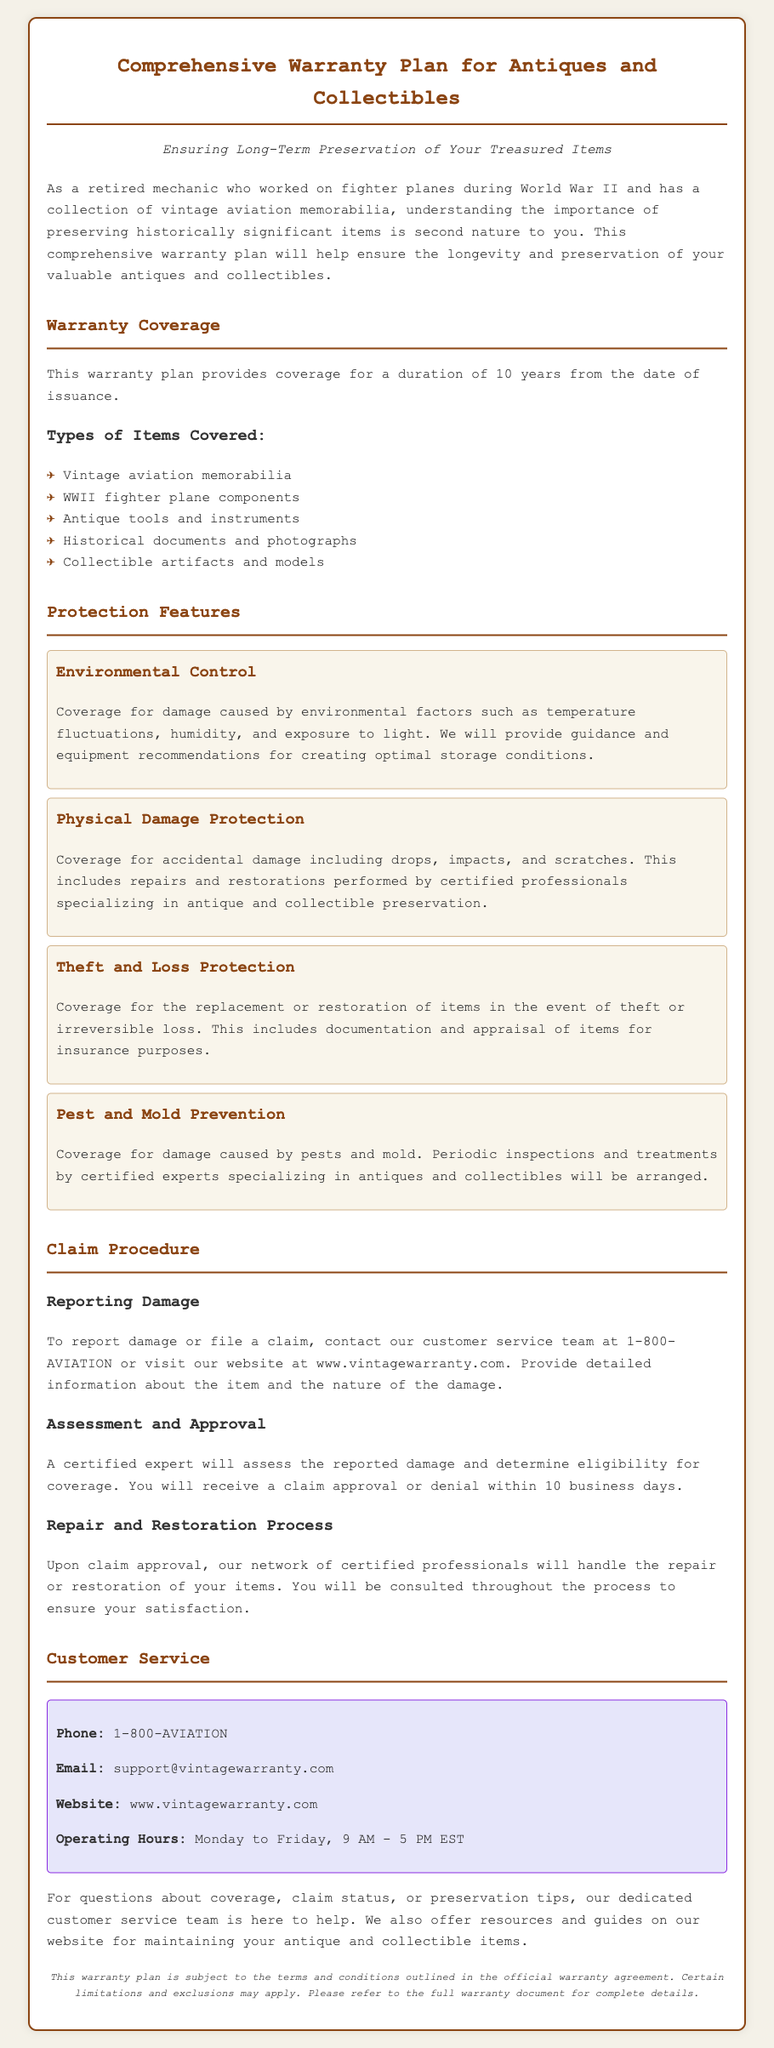What is the duration of the warranty plan? The document states that the warranty plan provides coverage for a duration of 10 years from the date of issuance.
Answer: 10 years What types of items are covered under this warranty? The document lists several types of items covered, including vintage aviation memorabilia and WWII fighter plane components.
Answer: Vintage aviation memorabilia, WWII fighter plane components, antique tools and instruments, historical documents and photographs, collectible artifacts and models What protection feature deals with environmental factors? The feature that relates to environmental factors is titled "Environmental Control."
Answer: Environmental Control What is the first step in the claim procedure? The document mentions that to report damage or file a claim, you need to contact customer service.
Answer: Contact customer service How long does it take to receive claim approval or denial? The document specifies that you will receive a claim approval or denial within 10 business days.
Answer: 10 business days What is the contact phone number for customer service? The document provides a specific phone number for customer service inquiries.
Answer: 1-800-AVIATION What happens after claim approval? The document indicates that certified professionals will handle the repair or restoration after claim approval.
Answer: Certified professionals handle repair or restoration What is included in theft and loss protection? The document states that theft and loss protection includes replacement or restoration of items in the event of theft or irreversible loss.
Answer: Replacement or restoration of items 